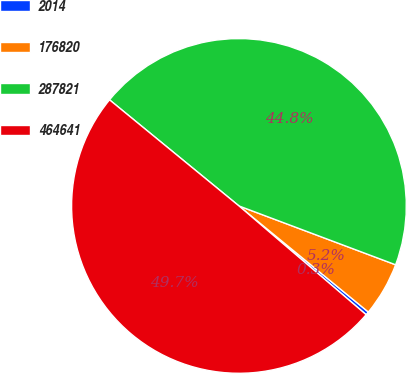Convert chart to OTSL. <chart><loc_0><loc_0><loc_500><loc_500><pie_chart><fcel>2014<fcel>176820<fcel>287821<fcel>464641<nl><fcel>0.33%<fcel>5.21%<fcel>44.79%<fcel>49.67%<nl></chart> 